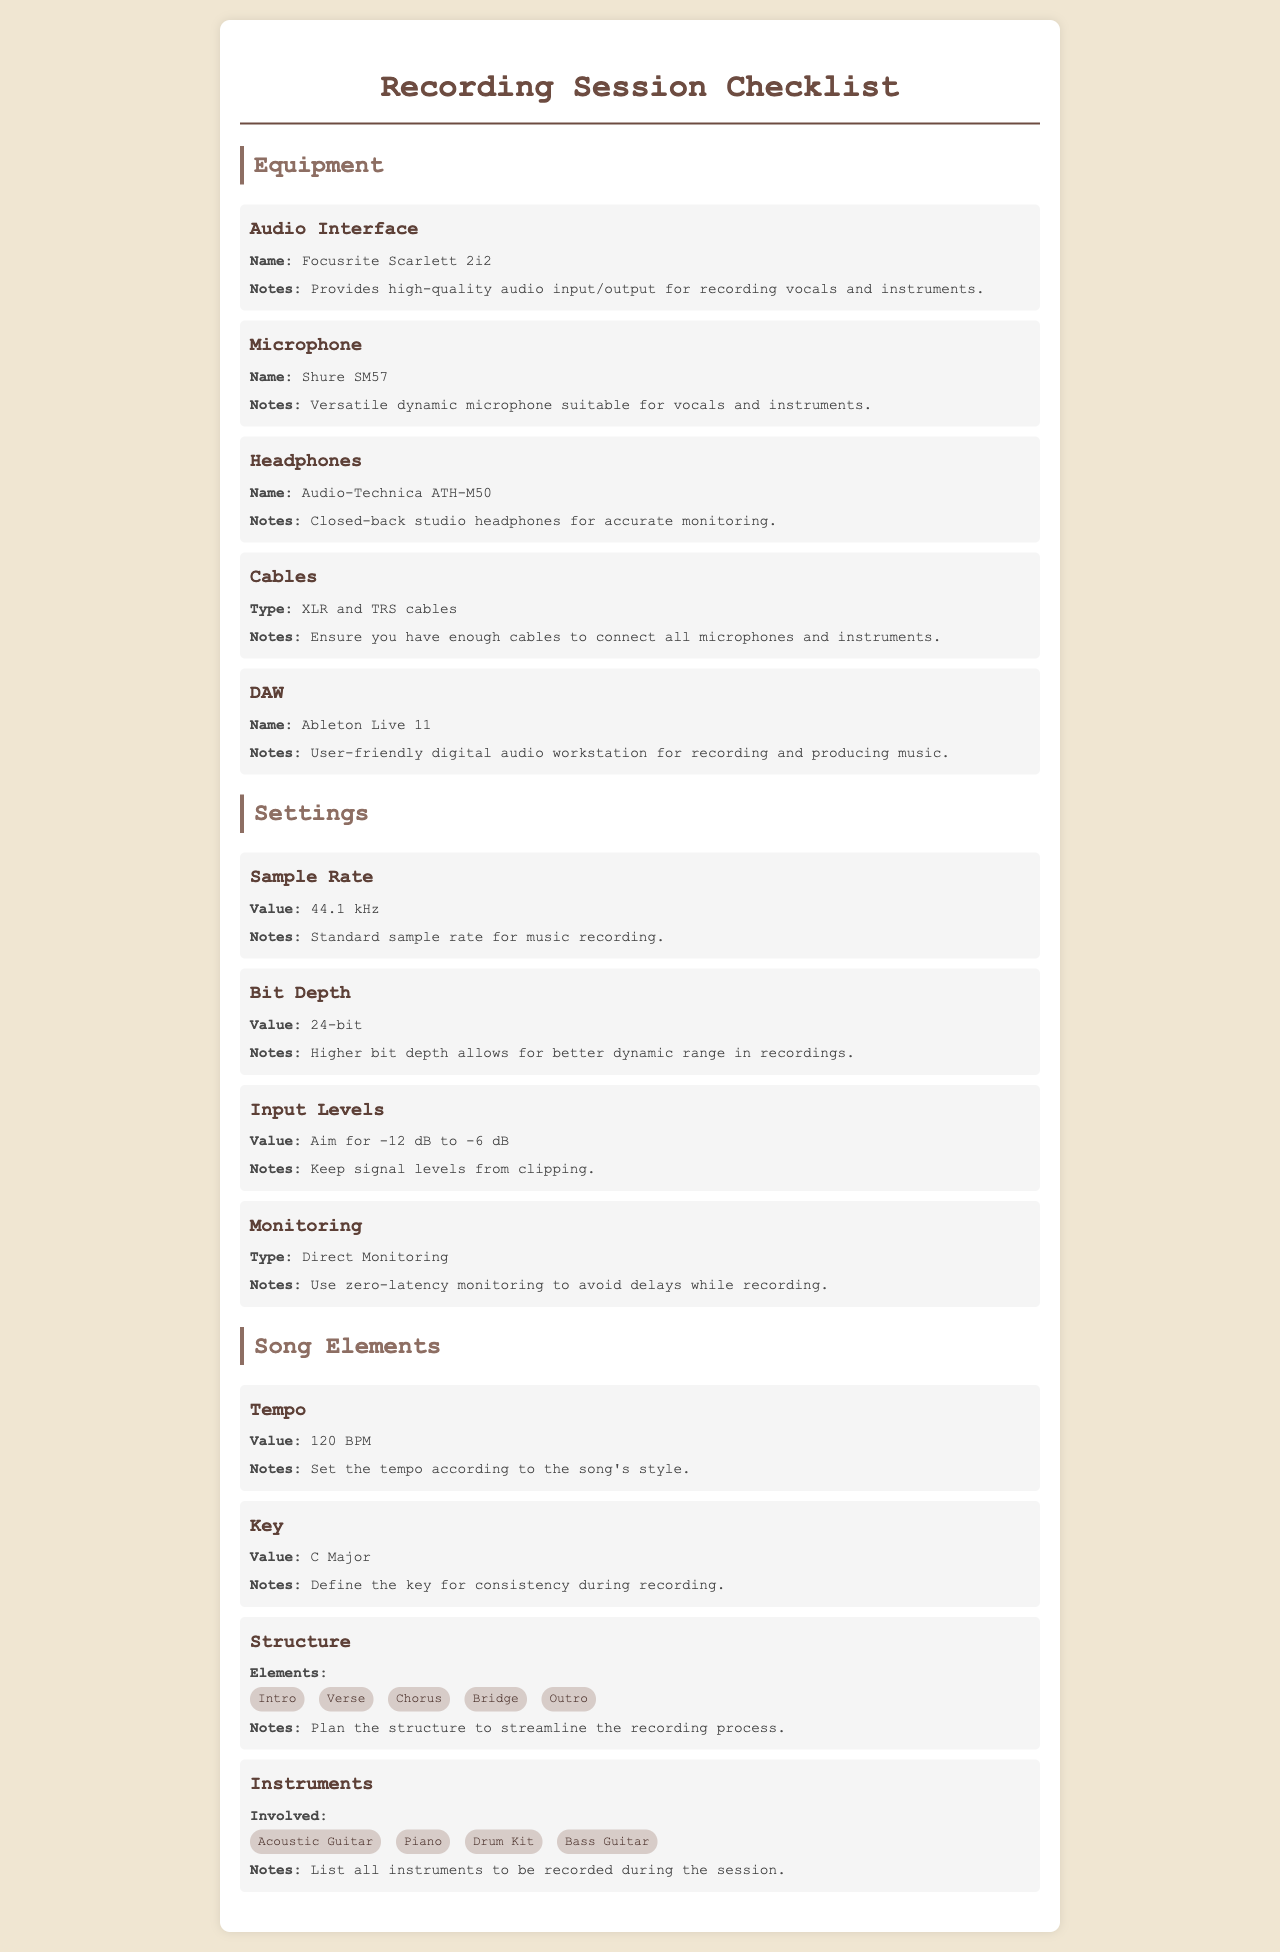What is the name of the audio interface? The audio interface mentioned in the checklist is the Focusrite Scarlett 2i2.
Answer: Focusrite Scarlett 2i2 What is the sample rate for recording? According to the checklist, the sample rate set for recording is 44.1 kHz.
Answer: 44.1 kHz What is the key specified in the song elements? The key defined for consistency during recording is C Major.
Answer: C Major What monitoring type should be used? The checklist advises using Direct Monitoring to avoid delays while recording.
Answer: Direct Monitoring What is the target input level range? The target input level range recommended is between -12 dB to -6 dB to prevent clipping.
Answer: -12 dB to -6 dB What are the instruments involved in the recording session? The checklist lists Acoustic Guitar, Piano, Drum Kit, and Bass Guitar as instruments involved.
Answer: Acoustic Guitar, Piano, Drum Kit, Bass Guitar What is the tempo set for the song? The tempo specified for the song is 120 BPM.
Answer: 120 BPM How many song structure elements are listed? The checklist lists five elements in the song structure: Intro, Verse, Chorus, Bridge, and Outro.
Answer: Five What headphones are recommended for monitoring? The headphones recommended for accurate monitoring are Audio-Technica ATH-M50.
Answer: Audio-Technica ATH-M50 